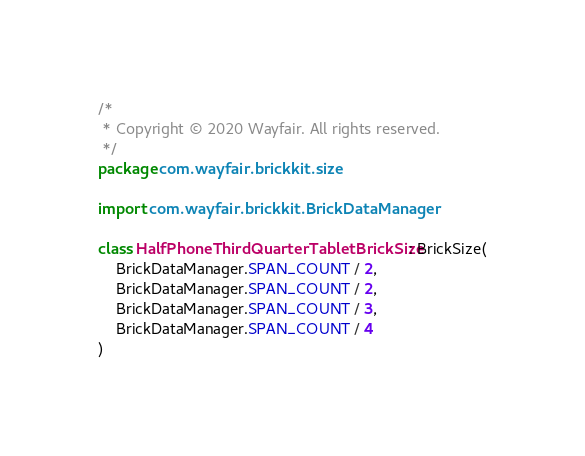Convert code to text. <code><loc_0><loc_0><loc_500><loc_500><_Kotlin_>/*
 * Copyright © 2020 Wayfair. All rights reserved.
 */
package com.wayfair.brickkit.size

import com.wayfair.brickkit.BrickDataManager

class HalfPhoneThirdQuarterTabletBrickSize : BrickSize(
    BrickDataManager.SPAN_COUNT / 2,
    BrickDataManager.SPAN_COUNT / 2,
    BrickDataManager.SPAN_COUNT / 3,
    BrickDataManager.SPAN_COUNT / 4
)
</code> 